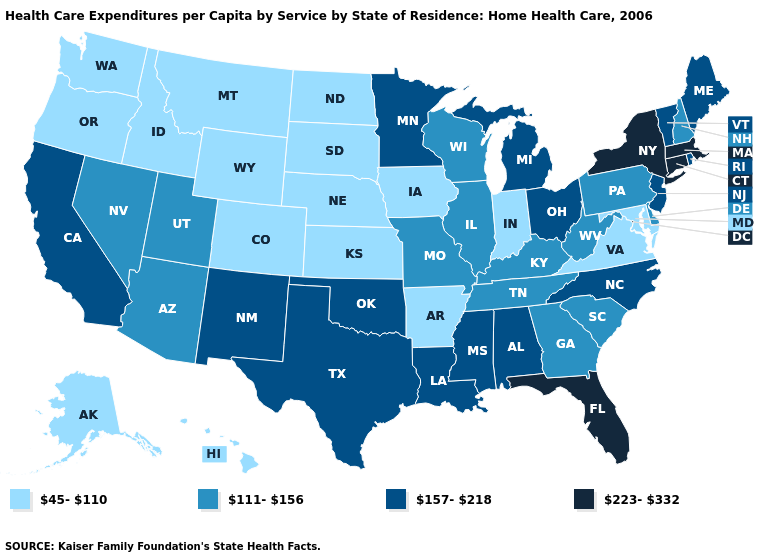What is the value of New Hampshire?
Write a very short answer. 111-156. Name the states that have a value in the range 111-156?
Give a very brief answer. Arizona, Delaware, Georgia, Illinois, Kentucky, Missouri, Nevada, New Hampshire, Pennsylvania, South Carolina, Tennessee, Utah, West Virginia, Wisconsin. Name the states that have a value in the range 157-218?
Quick response, please. Alabama, California, Louisiana, Maine, Michigan, Minnesota, Mississippi, New Jersey, New Mexico, North Carolina, Ohio, Oklahoma, Rhode Island, Texas, Vermont. Among the states that border Pennsylvania , which have the highest value?
Short answer required. New York. What is the value of New Jersey?
Short answer required. 157-218. What is the value of Alaska?
Quick response, please. 45-110. Name the states that have a value in the range 45-110?
Quick response, please. Alaska, Arkansas, Colorado, Hawaii, Idaho, Indiana, Iowa, Kansas, Maryland, Montana, Nebraska, North Dakota, Oregon, South Dakota, Virginia, Washington, Wyoming. What is the value of Louisiana?
Concise answer only. 157-218. Does the first symbol in the legend represent the smallest category?
Be succinct. Yes. Name the states that have a value in the range 111-156?
Keep it brief. Arizona, Delaware, Georgia, Illinois, Kentucky, Missouri, Nevada, New Hampshire, Pennsylvania, South Carolina, Tennessee, Utah, West Virginia, Wisconsin. Does Delaware have the same value as Maine?
Short answer required. No. Which states hav the highest value in the Northeast?
Keep it brief. Connecticut, Massachusetts, New York. What is the value of Iowa?
Write a very short answer. 45-110. What is the lowest value in the West?
Quick response, please. 45-110. What is the lowest value in the Northeast?
Write a very short answer. 111-156. 